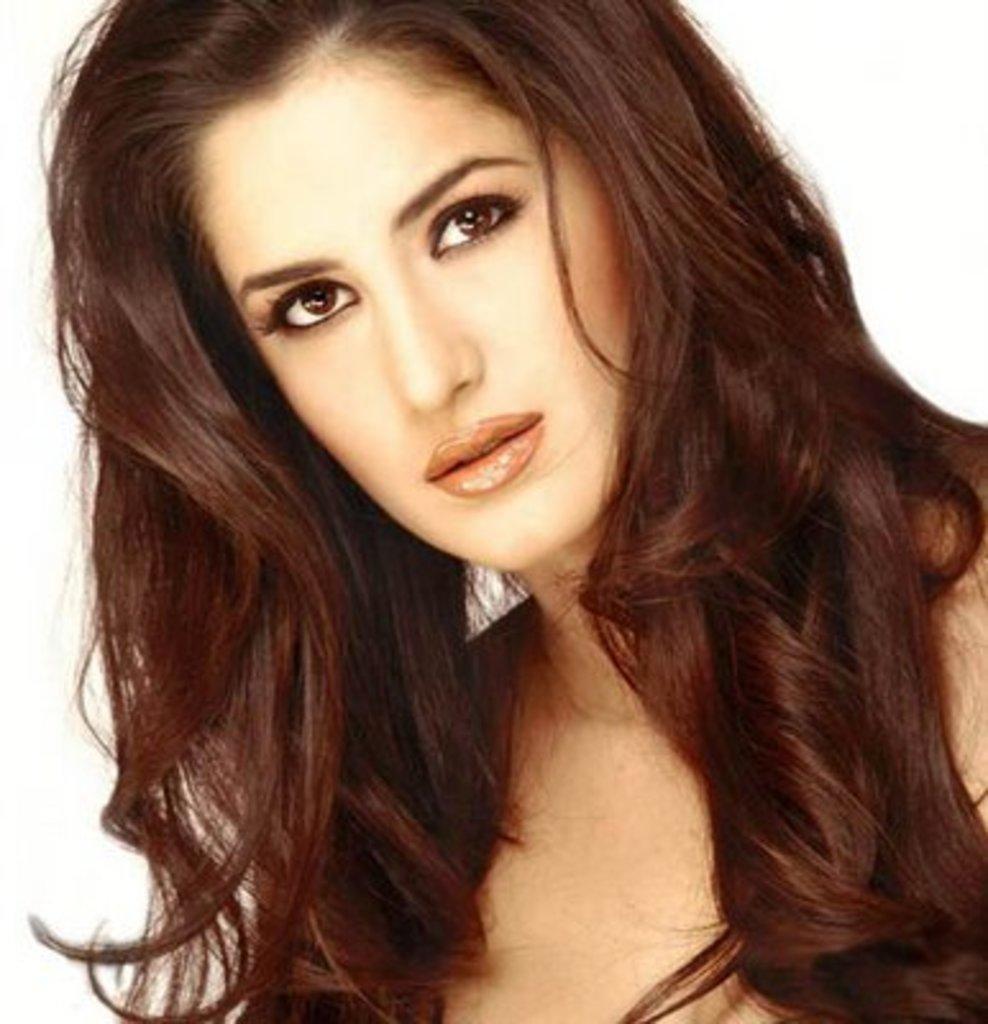In one or two sentences, can you explain what this image depicts? In this picture we can see a woman here, we can see a white background. 